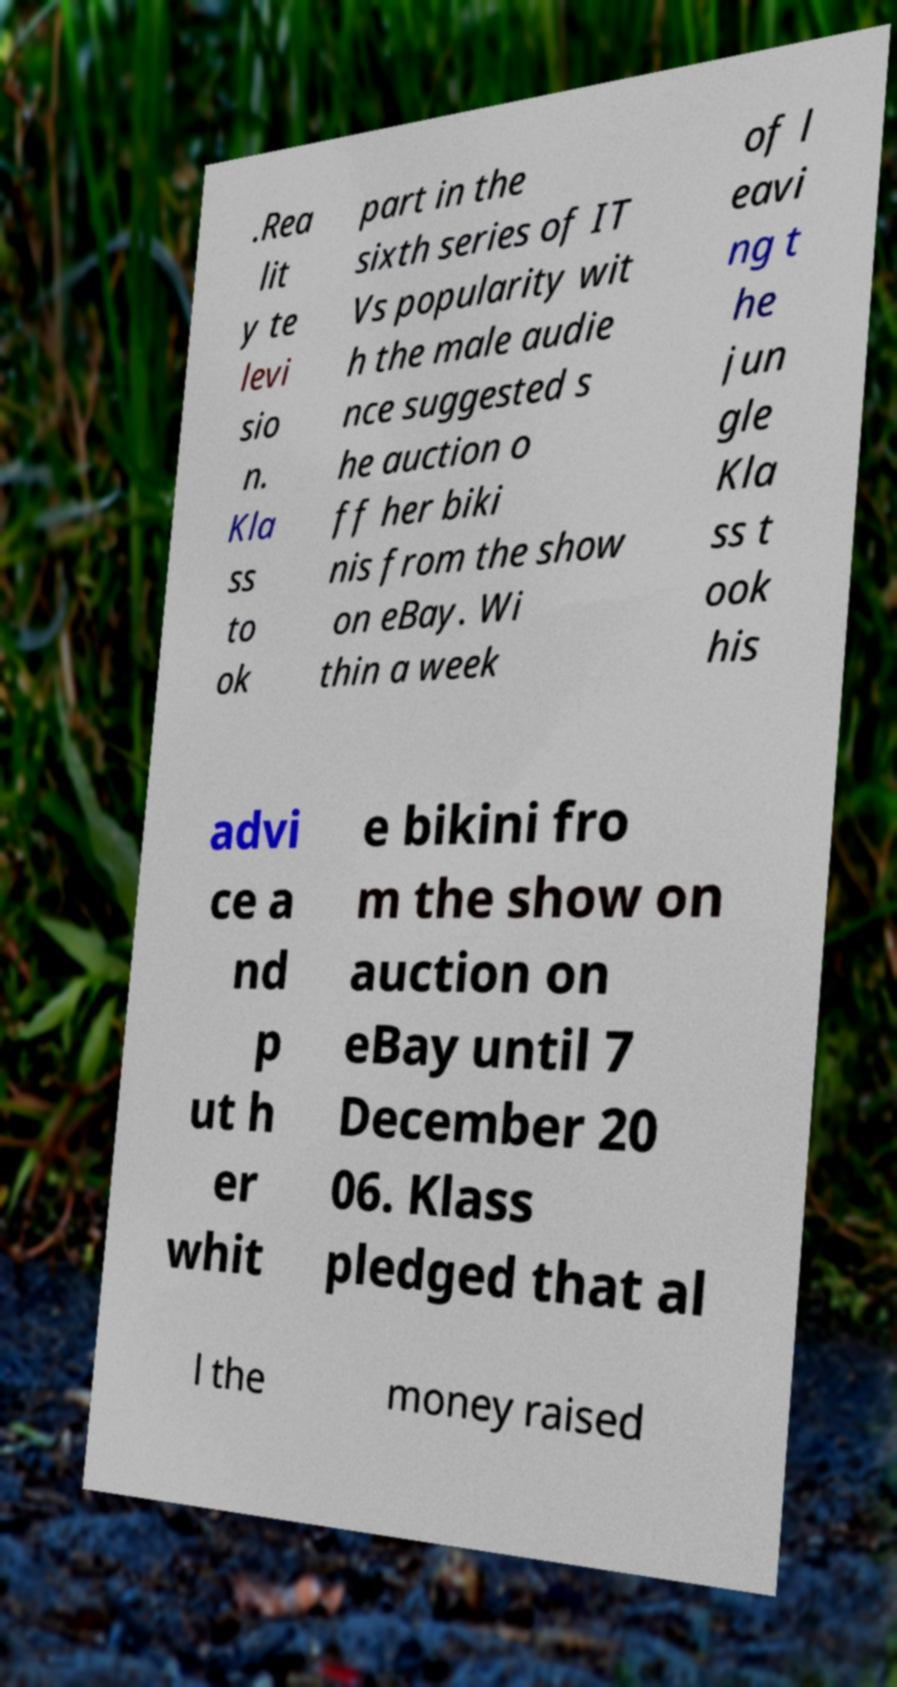Could you extract and type out the text from this image? .Rea lit y te levi sio n. Kla ss to ok part in the sixth series of IT Vs popularity wit h the male audie nce suggested s he auction o ff her biki nis from the show on eBay. Wi thin a week of l eavi ng t he jun gle Kla ss t ook his advi ce a nd p ut h er whit e bikini fro m the show on auction on eBay until 7 December 20 06. Klass pledged that al l the money raised 